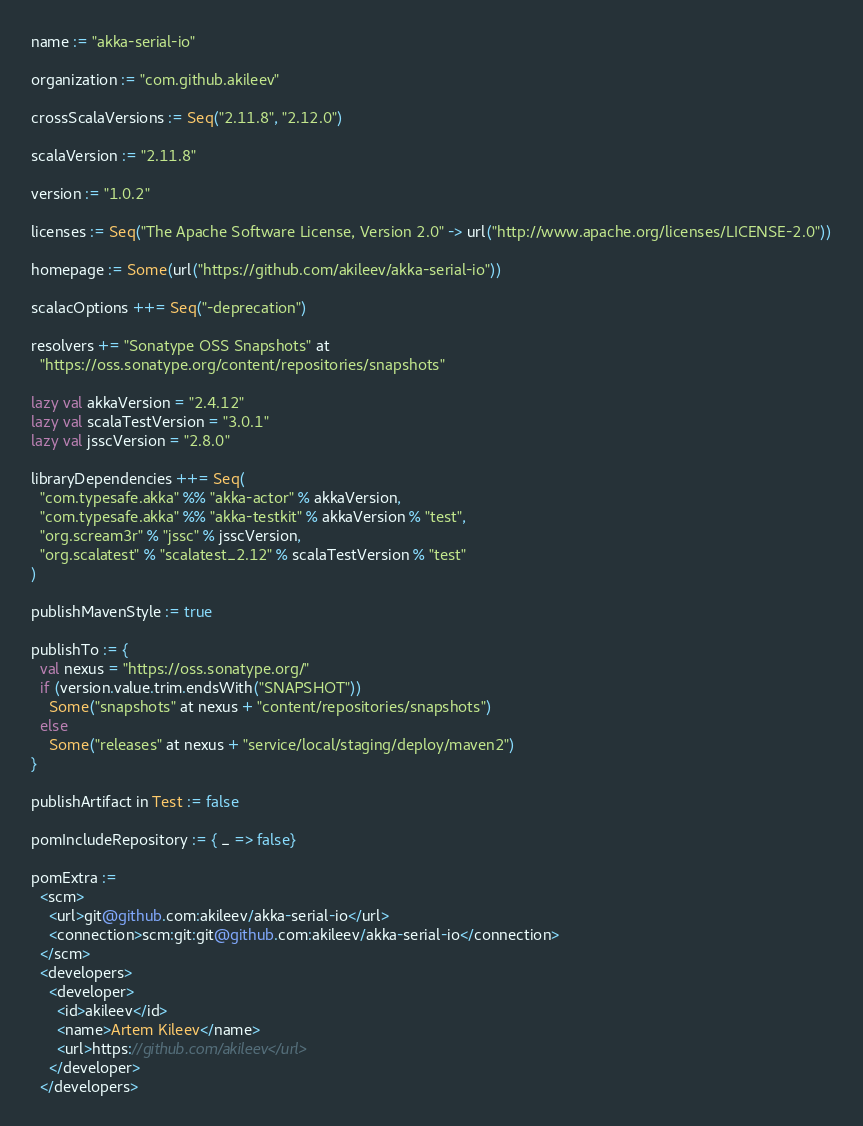<code> <loc_0><loc_0><loc_500><loc_500><_Scala_>name := "akka-serial-io"

organization := "com.github.akileev"

crossScalaVersions := Seq("2.11.8", "2.12.0")

scalaVersion := "2.11.8"

version := "1.0.2"

licenses := Seq("The Apache Software License, Version 2.0" -> url("http://www.apache.org/licenses/LICENSE-2.0"))

homepage := Some(url("https://github.com/akileev/akka-serial-io"))

scalacOptions ++= Seq("-deprecation")

resolvers += "Sonatype OSS Snapshots" at
  "https://oss.sonatype.org/content/repositories/snapshots"

lazy val akkaVersion = "2.4.12"
lazy val scalaTestVersion = "3.0.1"
lazy val jsscVersion = "2.8.0"

libraryDependencies ++= Seq(
  "com.typesafe.akka" %% "akka-actor" % akkaVersion,
  "com.typesafe.akka" %% "akka-testkit" % akkaVersion % "test",
  "org.scream3r" % "jssc" % jsscVersion,
  "org.scalatest" % "scalatest_2.12" % scalaTestVersion % "test"
)

publishMavenStyle := true

publishTo := {
  val nexus = "https://oss.sonatype.org/"
  if (version.value.trim.endsWith("SNAPSHOT"))
    Some("snapshots" at nexus + "content/repositories/snapshots")
  else
    Some("releases" at nexus + "service/local/staging/deploy/maven2")
}

publishArtifact in Test := false

pomIncludeRepository := { _ => false}

pomExtra :=
  <scm>
    <url>git@github.com:akileev/akka-serial-io</url>
    <connection>scm:git:git@github.com:akileev/akka-serial-io</connection>
  </scm>
  <developers>
    <developer>
      <id>akileev</id>
      <name>Artem Kileev</name>
      <url>https://github.com/akileev</url>
    </developer>
  </developers>
</code> 